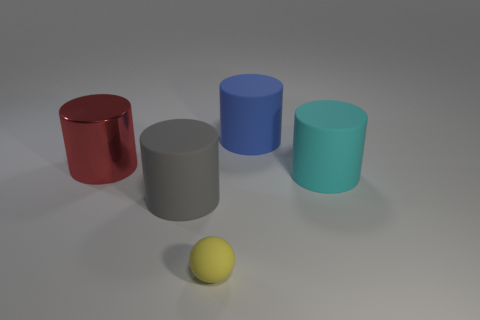How many small balls are behind the matte thing on the left side of the tiny yellow sphere?
Your answer should be very brief. 0. How many red cylinders are the same material as the gray thing?
Ensure brevity in your answer.  0. Are there any big matte cylinders behind the big blue matte cylinder?
Ensure brevity in your answer.  No. There is another metallic thing that is the same size as the blue thing; what color is it?
Make the answer very short. Red. What number of objects are matte cylinders in front of the large red metal thing or green cylinders?
Your answer should be compact. 2. There is a object that is to the right of the large gray matte object and in front of the big cyan cylinder; how big is it?
Give a very brief answer. Small. What number of other objects are the same size as the red shiny thing?
Keep it short and to the point. 3. The big object that is left of the rubber cylinder in front of the object that is right of the large blue rubber cylinder is what color?
Your answer should be compact. Red. The large matte thing that is to the right of the yellow thing and in front of the blue rubber cylinder has what shape?
Provide a succinct answer. Cylinder. How many other things are the same shape as the big gray matte object?
Make the answer very short. 3. 